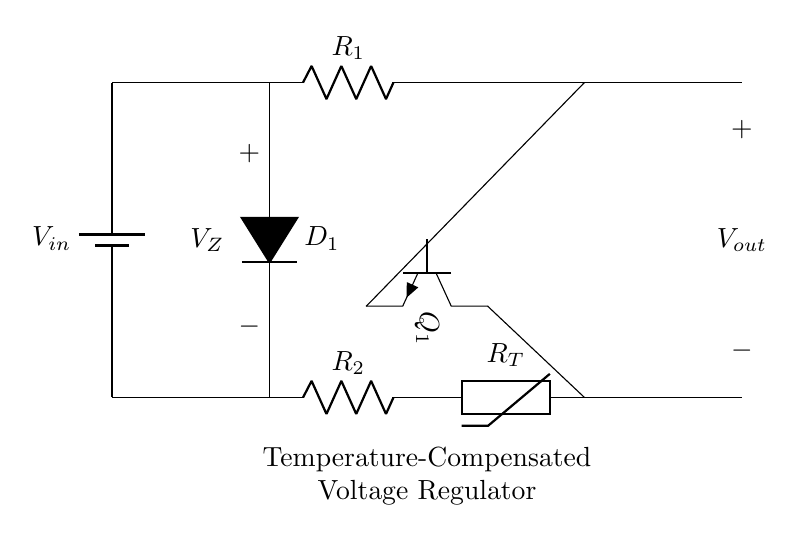What is the type of voltage regulator shown? The circuit diagram depicts a temperature-compensated voltage regulator, which is designed to maintain stable output voltage despite changes in temperature. The presence of a zener diode and thermistor indicates temperature compensation.
Answer: temperature-compensated voltage regulator What component regulates the output voltage? The zener diode, identified as D1 in the circuit, regulates the voltage by maintaining a constant voltage across its terminals when reverse-biased and adequately coupled with other elements like the transistor and resistors.
Answer: zener diode What is the function of the thermistor in the circuit? The thermistor, labeled RT, plays a crucial role in temperature compensation by changing its resistance with temperature fluctuations, impacting the biasing of the transistor and thus stabilizing the output voltage.
Answer: temperature compensation Which component in the circuit can dissipate the most power? The transistor, labeled Q1, is likely to dissipate the most power due to its active role in controlling current flow based on the input voltage and the feedback provided by the zener diode and thermistor.
Answer: transistor What is the voltage drop across the zener diode? The voltage drop across the zener diode, denoted as VZ, is maintained at a stable value that is chosen based on the design requirements of the circuit to ensure the output voltage remains constant under various conditions.
Answer: VZ How does the resistor R2 contribute to the circuit? Resistor R2 acts as a load resistor that impacts the current flowing through the thermistor and zener diode, influencing how the temperature changes affect the voltage regulation capabilities of the circuit.
Answer: load resistor What happens to the output voltage if the temperature increases? If the temperature increases, the thermistor resistance generally drops, allowing more current to flow through the transistor Q1, which dynamically adjusts to ensure the output voltage remains stable.
Answer: output remains stable 